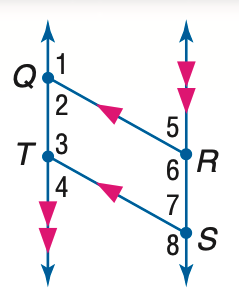Answer the mathemtical geometry problem and directly provide the correct option letter.
Question: In the figure, Q R \parallel T S, Q T \parallel R S, and m \angle 1 = 131. Find the measure of \angle 5.
Choices: A: 49 B: 59 C: 69 D: 79 A 